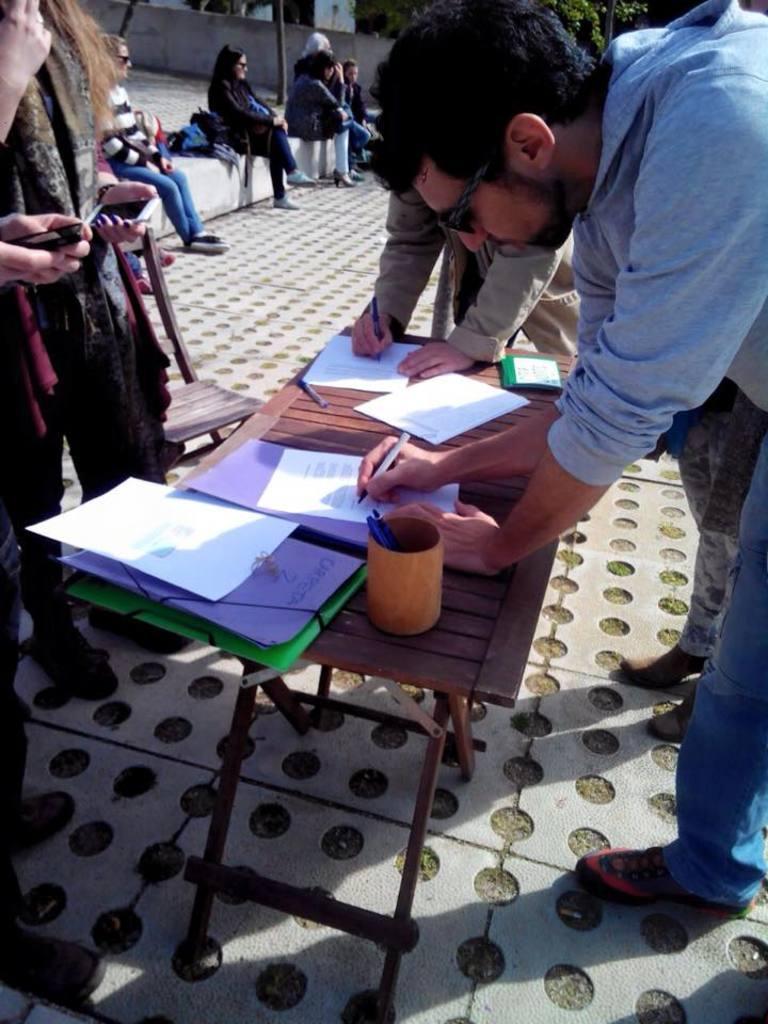Describe this image in one or two sentences. In this picture we can see some people standing and writing on paper placed on table and some are sitting on floor and here on table we can see pens, pen stand, files and in background we can see wall, trees. 